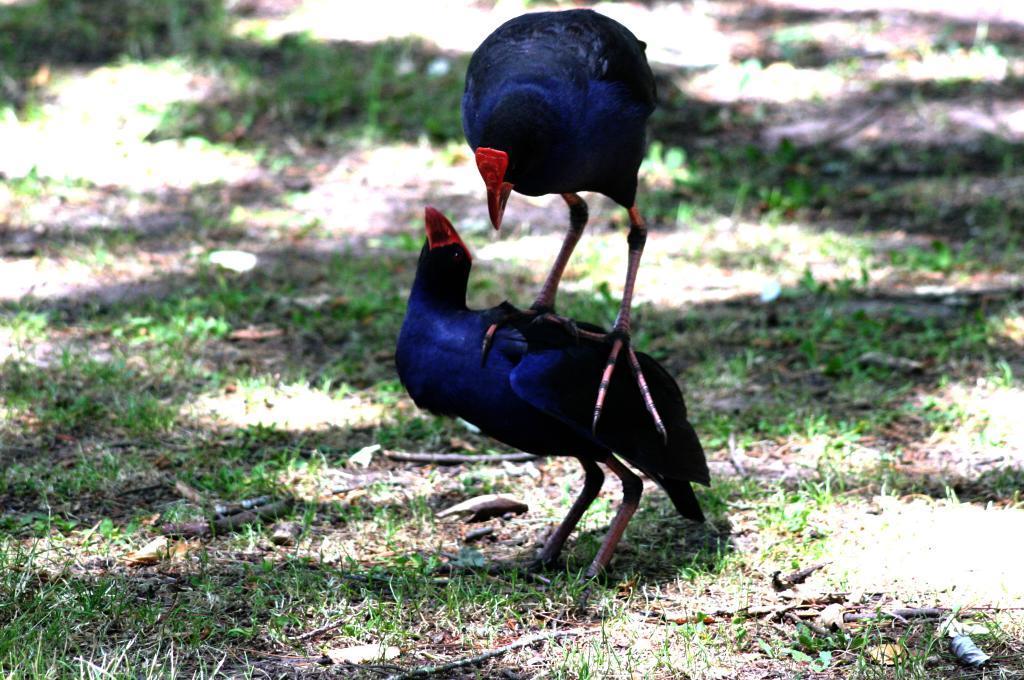Could you give a brief overview of what you see in this image? In this image we can see two birds. Around the birds we can see the grass. 